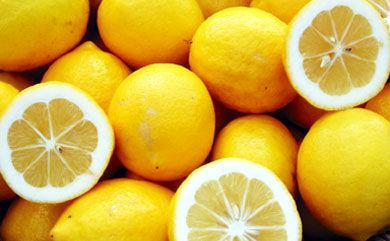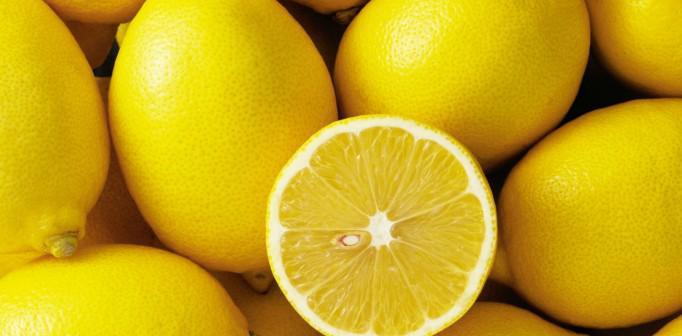The first image is the image on the left, the second image is the image on the right. Considering the images on both sides, is "There are at least two lemon halves that are cut open." valid? Answer yes or no. Yes. The first image is the image on the left, the second image is the image on the right. Analyze the images presented: Is the assertion "There is a sliced lemon in exactly one image." valid? Answer yes or no. No. 